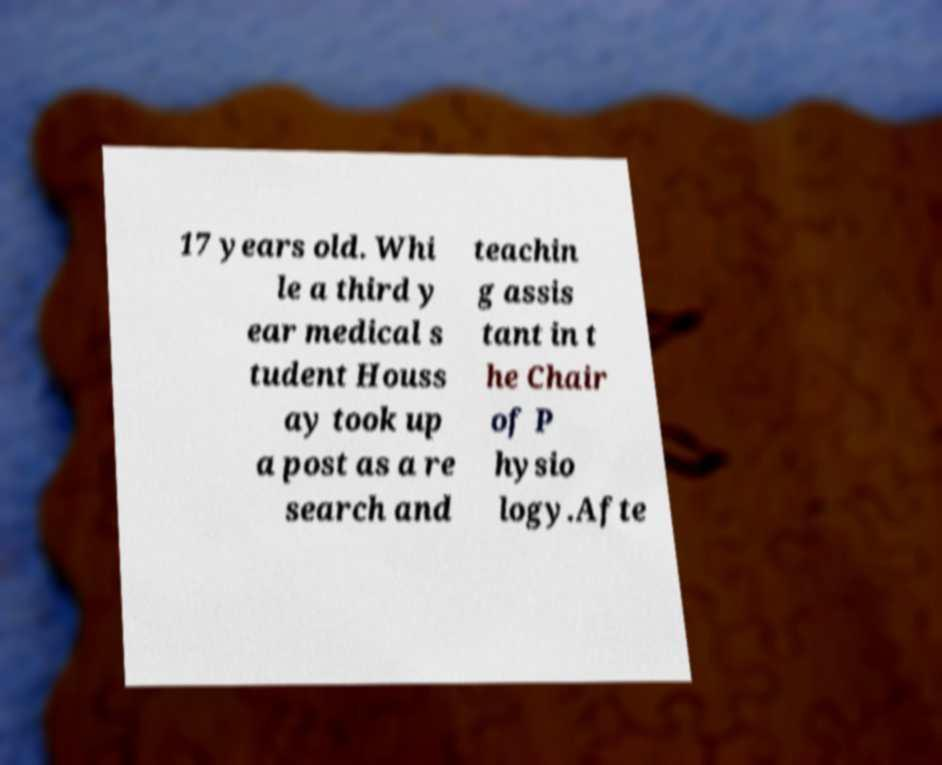For documentation purposes, I need the text within this image transcribed. Could you provide that? 17 years old. Whi le a third y ear medical s tudent Houss ay took up a post as a re search and teachin g assis tant in t he Chair of P hysio logy.Afte 